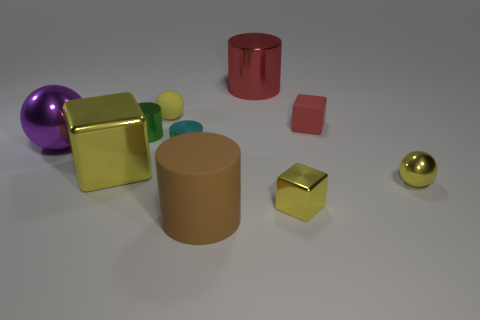Subtract all spheres. How many objects are left? 7 Subtract all small yellow matte balls. Subtract all large red metal cylinders. How many objects are left? 8 Add 6 big metallic cubes. How many big metallic cubes are left? 7 Add 8 big brown rubber objects. How many big brown rubber objects exist? 9 Subtract 0 gray cylinders. How many objects are left? 10 